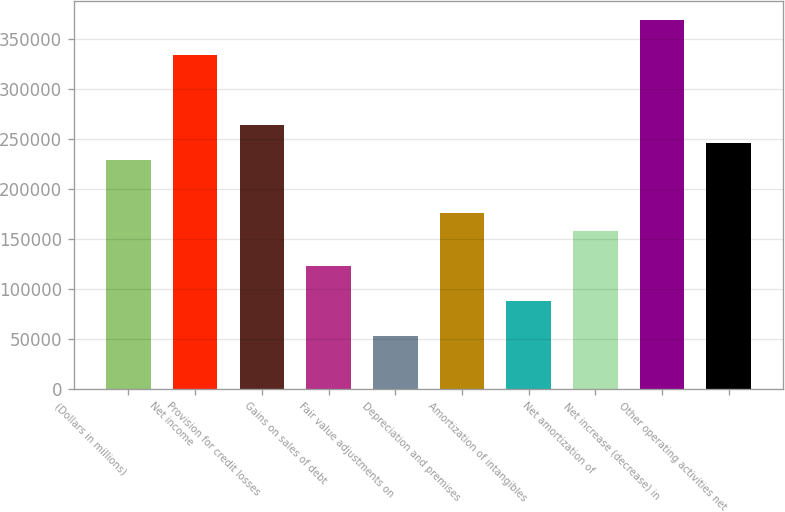Convert chart to OTSL. <chart><loc_0><loc_0><loc_500><loc_500><bar_chart><fcel>(Dollars in millions)<fcel>Net income<fcel>Provision for credit losses<fcel>Gains on sales of debt<fcel>Fair value adjustments on<fcel>Depreciation and premises<fcel>Amortization of intangibles<fcel>Net amortization of<fcel>Net increase (decrease) in<fcel>Other operating activities net<nl><fcel>228774<fcel>334357<fcel>263968<fcel>123192<fcel>52803.3<fcel>175983<fcel>87997.5<fcel>158386<fcel>369551<fcel>246371<nl></chart> 